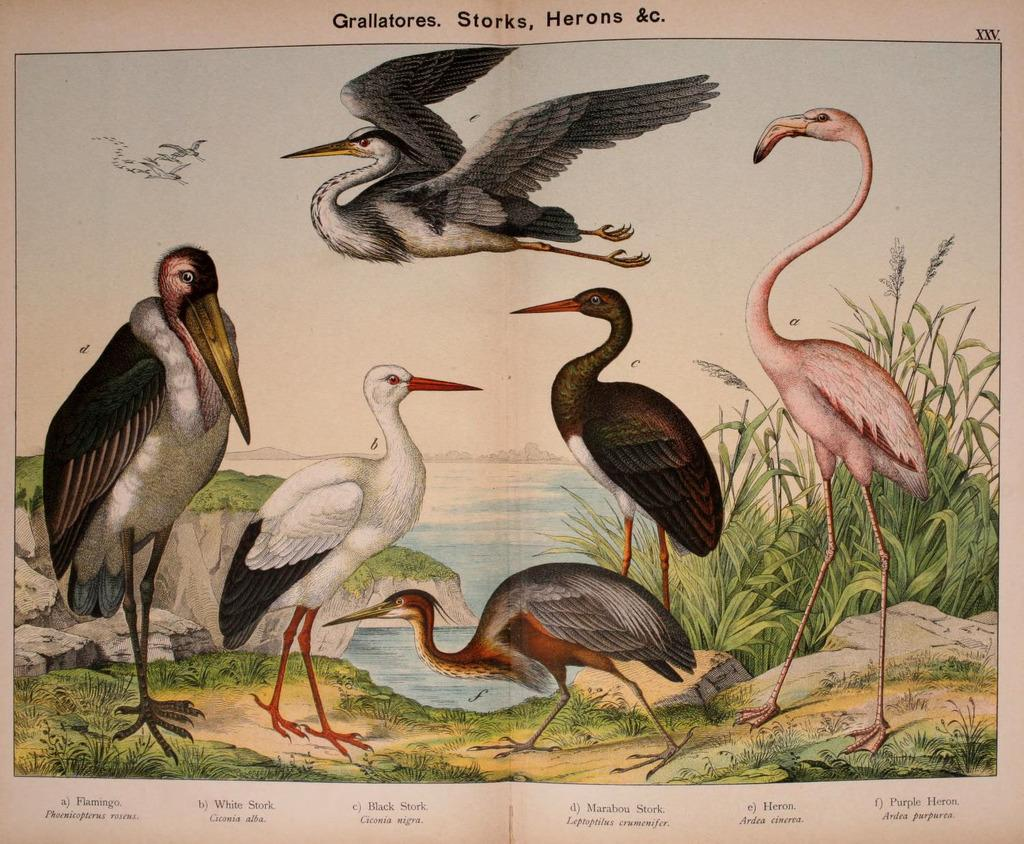What type of animals can be seen in the image? There are birds in the image. Where are the birds located? The birds are on a paper. What is written or visible at the bottom of the image? There is text at the bottom of the image. What is there is a note attached to the health of the birds in the image? There is no note or mention of the birds' health in the image. 